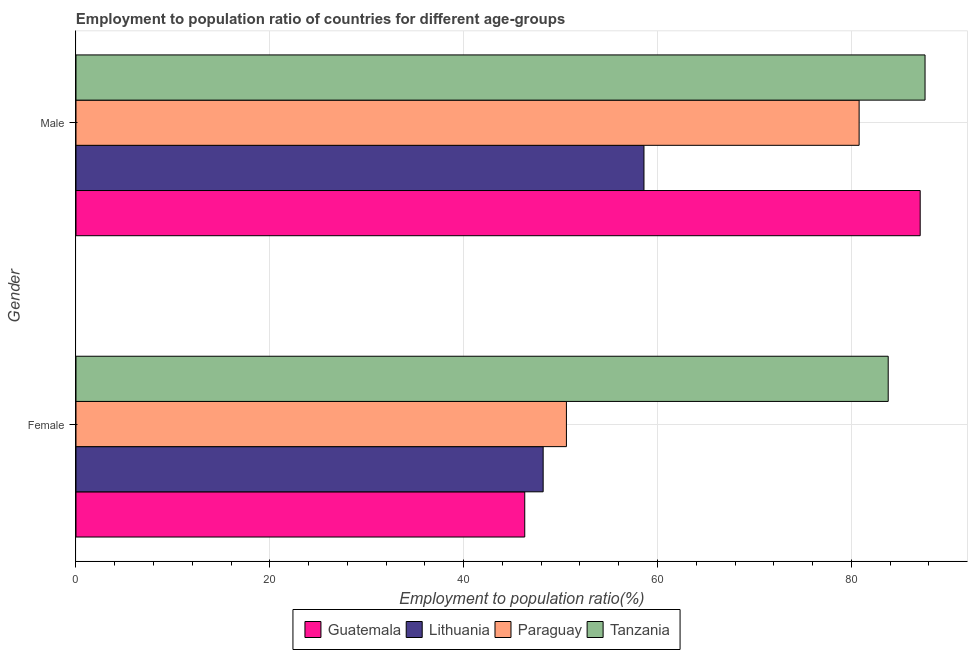Are the number of bars per tick equal to the number of legend labels?
Provide a short and direct response. Yes. How many bars are there on the 2nd tick from the top?
Give a very brief answer. 4. What is the label of the 2nd group of bars from the top?
Your response must be concise. Female. What is the employment to population ratio(male) in Guatemala?
Your answer should be compact. 87.1. Across all countries, what is the maximum employment to population ratio(male)?
Offer a terse response. 87.6. Across all countries, what is the minimum employment to population ratio(female)?
Provide a short and direct response. 46.3. In which country was the employment to population ratio(female) maximum?
Ensure brevity in your answer.  Tanzania. In which country was the employment to population ratio(female) minimum?
Offer a very short reply. Guatemala. What is the total employment to population ratio(female) in the graph?
Your answer should be compact. 228.9. What is the difference between the employment to population ratio(female) in Guatemala and that in Lithuania?
Your answer should be very brief. -1.9. What is the difference between the employment to population ratio(male) in Paraguay and the employment to population ratio(female) in Tanzania?
Ensure brevity in your answer.  -3. What is the average employment to population ratio(female) per country?
Make the answer very short. 57.23. What is the difference between the employment to population ratio(male) and employment to population ratio(female) in Guatemala?
Offer a very short reply. 40.8. In how many countries, is the employment to population ratio(male) greater than 8 %?
Provide a short and direct response. 4. What is the ratio of the employment to population ratio(female) in Paraguay to that in Tanzania?
Your response must be concise. 0.6. In how many countries, is the employment to population ratio(female) greater than the average employment to population ratio(female) taken over all countries?
Provide a succinct answer. 1. What does the 3rd bar from the top in Female represents?
Offer a terse response. Lithuania. What does the 4th bar from the bottom in Female represents?
Provide a short and direct response. Tanzania. How many bars are there?
Give a very brief answer. 8. How many countries are there in the graph?
Make the answer very short. 4. Are the values on the major ticks of X-axis written in scientific E-notation?
Give a very brief answer. No. Does the graph contain grids?
Keep it short and to the point. Yes. Where does the legend appear in the graph?
Offer a very short reply. Bottom center. How many legend labels are there?
Keep it short and to the point. 4. What is the title of the graph?
Give a very brief answer. Employment to population ratio of countries for different age-groups. What is the Employment to population ratio(%) in Guatemala in Female?
Your answer should be very brief. 46.3. What is the Employment to population ratio(%) in Lithuania in Female?
Your response must be concise. 48.2. What is the Employment to population ratio(%) of Paraguay in Female?
Give a very brief answer. 50.6. What is the Employment to population ratio(%) of Tanzania in Female?
Your answer should be very brief. 83.8. What is the Employment to population ratio(%) in Guatemala in Male?
Keep it short and to the point. 87.1. What is the Employment to population ratio(%) in Lithuania in Male?
Ensure brevity in your answer.  58.6. What is the Employment to population ratio(%) in Paraguay in Male?
Make the answer very short. 80.8. What is the Employment to population ratio(%) of Tanzania in Male?
Keep it short and to the point. 87.6. Across all Gender, what is the maximum Employment to population ratio(%) of Guatemala?
Offer a very short reply. 87.1. Across all Gender, what is the maximum Employment to population ratio(%) in Lithuania?
Your answer should be very brief. 58.6. Across all Gender, what is the maximum Employment to population ratio(%) of Paraguay?
Provide a succinct answer. 80.8. Across all Gender, what is the maximum Employment to population ratio(%) in Tanzania?
Provide a succinct answer. 87.6. Across all Gender, what is the minimum Employment to population ratio(%) in Guatemala?
Provide a short and direct response. 46.3. Across all Gender, what is the minimum Employment to population ratio(%) of Lithuania?
Your answer should be very brief. 48.2. Across all Gender, what is the minimum Employment to population ratio(%) in Paraguay?
Keep it short and to the point. 50.6. Across all Gender, what is the minimum Employment to population ratio(%) in Tanzania?
Ensure brevity in your answer.  83.8. What is the total Employment to population ratio(%) of Guatemala in the graph?
Your answer should be very brief. 133.4. What is the total Employment to population ratio(%) of Lithuania in the graph?
Offer a very short reply. 106.8. What is the total Employment to population ratio(%) in Paraguay in the graph?
Ensure brevity in your answer.  131.4. What is the total Employment to population ratio(%) in Tanzania in the graph?
Ensure brevity in your answer.  171.4. What is the difference between the Employment to population ratio(%) in Guatemala in Female and that in Male?
Your response must be concise. -40.8. What is the difference between the Employment to population ratio(%) of Paraguay in Female and that in Male?
Offer a very short reply. -30.2. What is the difference between the Employment to population ratio(%) of Tanzania in Female and that in Male?
Provide a succinct answer. -3.8. What is the difference between the Employment to population ratio(%) in Guatemala in Female and the Employment to population ratio(%) in Lithuania in Male?
Offer a very short reply. -12.3. What is the difference between the Employment to population ratio(%) of Guatemala in Female and the Employment to population ratio(%) of Paraguay in Male?
Keep it short and to the point. -34.5. What is the difference between the Employment to population ratio(%) in Guatemala in Female and the Employment to population ratio(%) in Tanzania in Male?
Your answer should be very brief. -41.3. What is the difference between the Employment to population ratio(%) of Lithuania in Female and the Employment to population ratio(%) of Paraguay in Male?
Make the answer very short. -32.6. What is the difference between the Employment to population ratio(%) of Lithuania in Female and the Employment to population ratio(%) of Tanzania in Male?
Offer a terse response. -39.4. What is the difference between the Employment to population ratio(%) in Paraguay in Female and the Employment to population ratio(%) in Tanzania in Male?
Ensure brevity in your answer.  -37. What is the average Employment to population ratio(%) of Guatemala per Gender?
Offer a very short reply. 66.7. What is the average Employment to population ratio(%) of Lithuania per Gender?
Ensure brevity in your answer.  53.4. What is the average Employment to population ratio(%) in Paraguay per Gender?
Ensure brevity in your answer.  65.7. What is the average Employment to population ratio(%) in Tanzania per Gender?
Provide a succinct answer. 85.7. What is the difference between the Employment to population ratio(%) in Guatemala and Employment to population ratio(%) in Tanzania in Female?
Your response must be concise. -37.5. What is the difference between the Employment to population ratio(%) in Lithuania and Employment to population ratio(%) in Tanzania in Female?
Offer a very short reply. -35.6. What is the difference between the Employment to population ratio(%) in Paraguay and Employment to population ratio(%) in Tanzania in Female?
Keep it short and to the point. -33.2. What is the difference between the Employment to population ratio(%) in Guatemala and Employment to population ratio(%) in Lithuania in Male?
Provide a short and direct response. 28.5. What is the difference between the Employment to population ratio(%) of Guatemala and Employment to population ratio(%) of Paraguay in Male?
Make the answer very short. 6.3. What is the difference between the Employment to population ratio(%) in Guatemala and Employment to population ratio(%) in Tanzania in Male?
Your response must be concise. -0.5. What is the difference between the Employment to population ratio(%) of Lithuania and Employment to population ratio(%) of Paraguay in Male?
Keep it short and to the point. -22.2. What is the difference between the Employment to population ratio(%) of Paraguay and Employment to population ratio(%) of Tanzania in Male?
Offer a very short reply. -6.8. What is the ratio of the Employment to population ratio(%) in Guatemala in Female to that in Male?
Your answer should be very brief. 0.53. What is the ratio of the Employment to population ratio(%) in Lithuania in Female to that in Male?
Provide a succinct answer. 0.82. What is the ratio of the Employment to population ratio(%) of Paraguay in Female to that in Male?
Provide a succinct answer. 0.63. What is the ratio of the Employment to population ratio(%) of Tanzania in Female to that in Male?
Your answer should be compact. 0.96. What is the difference between the highest and the second highest Employment to population ratio(%) of Guatemala?
Keep it short and to the point. 40.8. What is the difference between the highest and the second highest Employment to population ratio(%) of Lithuania?
Your answer should be very brief. 10.4. What is the difference between the highest and the second highest Employment to population ratio(%) in Paraguay?
Offer a terse response. 30.2. What is the difference between the highest and the second highest Employment to population ratio(%) of Tanzania?
Offer a terse response. 3.8. What is the difference between the highest and the lowest Employment to population ratio(%) of Guatemala?
Your answer should be compact. 40.8. What is the difference between the highest and the lowest Employment to population ratio(%) in Lithuania?
Give a very brief answer. 10.4. What is the difference between the highest and the lowest Employment to population ratio(%) in Paraguay?
Your answer should be compact. 30.2. 